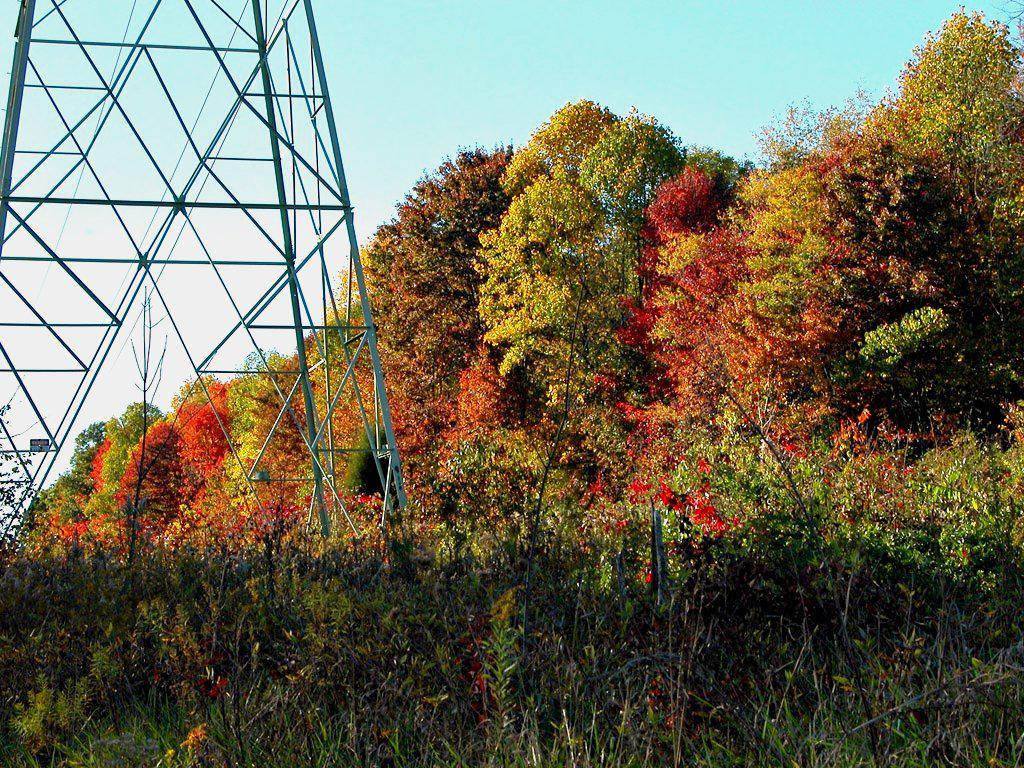What types of vegetation are present at the bottom of the image? There are plants and trees at the bottom of the image. What structure can be seen on the left side of the image? There is a tower on the left side of the image. What can be seen in the background of the image? There are trees and clouds in the sky in the background of the image. How many shoes are hanging from the trees in the image? There are no shoes present in the image; it features plants, trees, and a tower. What unit of measurement is used to determine the height of the clouds in the image? There is no measurement provided in the image, and the height of the clouds cannot be determined. 